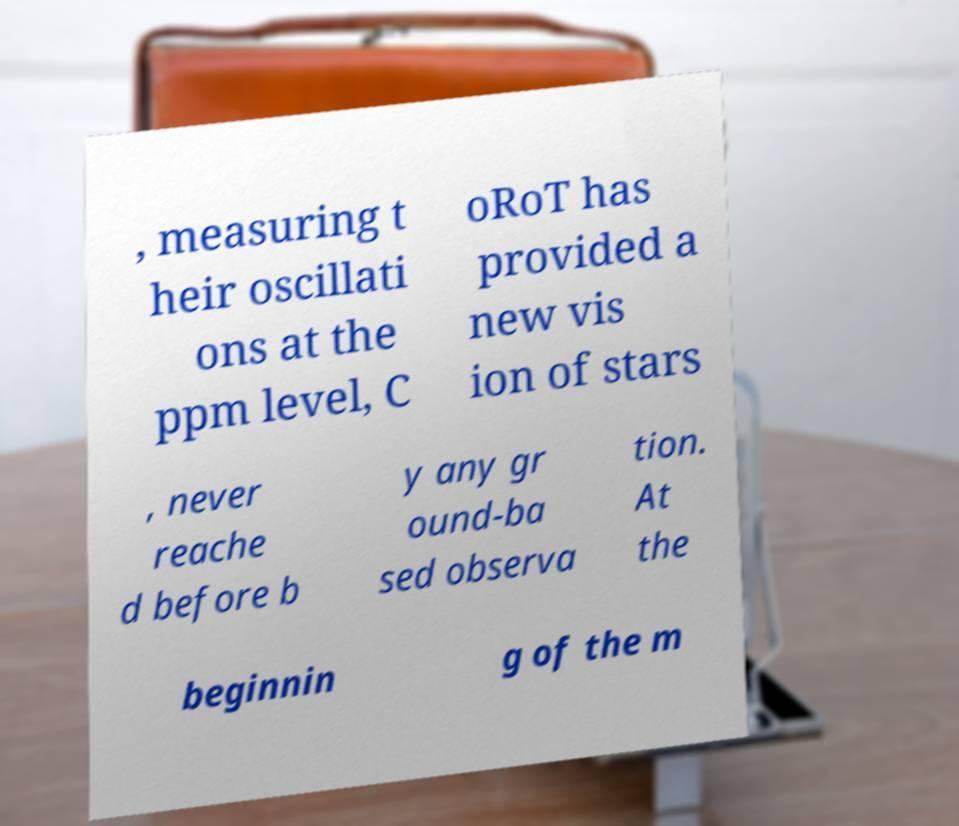Can you accurately transcribe the text from the provided image for me? , measuring t heir oscillati ons at the ppm level, C oRoT has provided a new vis ion of stars , never reache d before b y any gr ound-ba sed observa tion. At the beginnin g of the m 